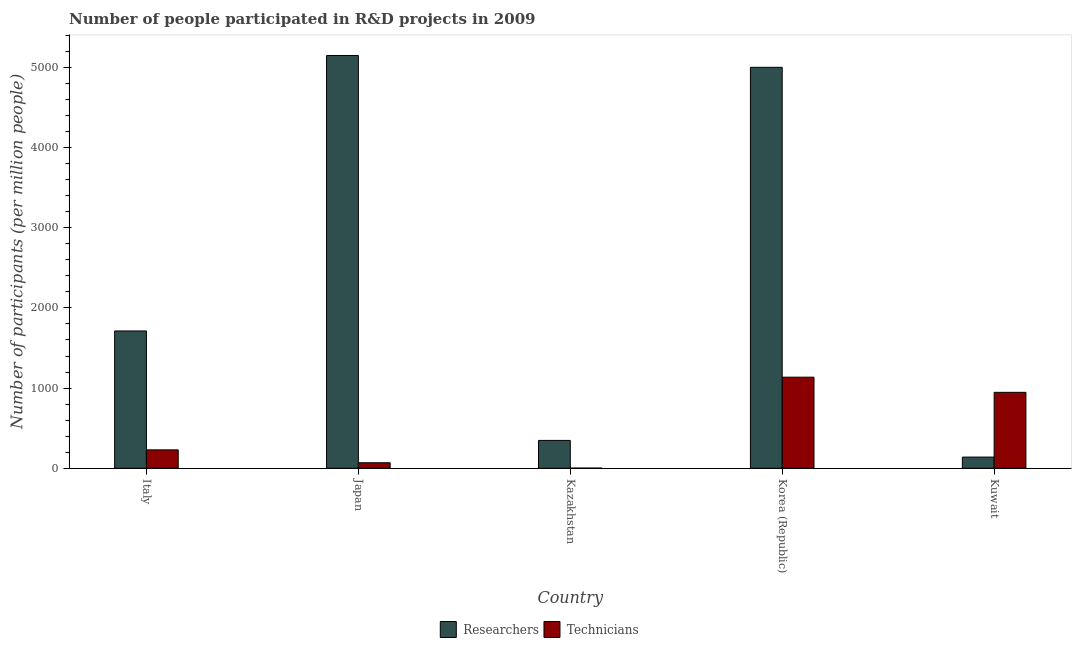How many different coloured bars are there?
Make the answer very short. 2. How many groups of bars are there?
Keep it short and to the point. 5. Are the number of bars per tick equal to the number of legend labels?
Provide a short and direct response. Yes. What is the label of the 2nd group of bars from the left?
Your answer should be very brief. Japan. In how many cases, is the number of bars for a given country not equal to the number of legend labels?
Ensure brevity in your answer.  0. What is the number of technicians in Kazakhstan?
Keep it short and to the point. 2.01. Across all countries, what is the maximum number of researchers?
Your answer should be compact. 5147.84. Across all countries, what is the minimum number of technicians?
Offer a terse response. 2.01. In which country was the number of researchers maximum?
Make the answer very short. Japan. In which country was the number of researchers minimum?
Give a very brief answer. Kuwait. What is the total number of technicians in the graph?
Offer a terse response. 2383.41. What is the difference between the number of researchers in Italy and that in Kuwait?
Keep it short and to the point. 1573.02. What is the difference between the number of researchers in Italy and the number of technicians in Kazakhstan?
Provide a succinct answer. 1710.54. What is the average number of technicians per country?
Your answer should be very brief. 476.68. What is the difference between the number of technicians and number of researchers in Korea (Republic)?
Make the answer very short. -3864.88. What is the ratio of the number of technicians in Japan to that in Korea (Republic)?
Provide a short and direct response. 0.06. Is the number of researchers in Italy less than that in Kazakhstan?
Ensure brevity in your answer.  No. What is the difference between the highest and the second highest number of technicians?
Make the answer very short. 188.9. What is the difference between the highest and the lowest number of technicians?
Provide a succinct answer. 1133.97. In how many countries, is the number of technicians greater than the average number of technicians taken over all countries?
Your answer should be very brief. 2. What does the 2nd bar from the left in Italy represents?
Keep it short and to the point. Technicians. What does the 2nd bar from the right in Japan represents?
Your answer should be very brief. Researchers. How many countries are there in the graph?
Your answer should be very brief. 5. Are the values on the major ticks of Y-axis written in scientific E-notation?
Provide a succinct answer. No. Does the graph contain any zero values?
Your answer should be very brief. No. Does the graph contain grids?
Your answer should be compact. No. Where does the legend appear in the graph?
Offer a terse response. Bottom center. What is the title of the graph?
Provide a short and direct response. Number of people participated in R&D projects in 2009. Does "Age 65(female)" appear as one of the legend labels in the graph?
Give a very brief answer. No. What is the label or title of the X-axis?
Keep it short and to the point. Country. What is the label or title of the Y-axis?
Provide a short and direct response. Number of participants (per million people). What is the Number of participants (per million people) in Researchers in Italy?
Your answer should be very brief. 1712.54. What is the Number of participants (per million people) in Technicians in Italy?
Provide a succinct answer. 229.5. What is the Number of participants (per million people) in Researchers in Japan?
Keep it short and to the point. 5147.84. What is the Number of participants (per million people) in Technicians in Japan?
Your answer should be very brief. 68.85. What is the Number of participants (per million people) of Researchers in Kazakhstan?
Ensure brevity in your answer.  347.43. What is the Number of participants (per million people) in Technicians in Kazakhstan?
Give a very brief answer. 2.01. What is the Number of participants (per million people) in Researchers in Korea (Republic)?
Your answer should be very brief. 5000.85. What is the Number of participants (per million people) of Technicians in Korea (Republic)?
Make the answer very short. 1135.98. What is the Number of participants (per million people) of Researchers in Kuwait?
Your response must be concise. 139.52. What is the Number of participants (per million people) of Technicians in Kuwait?
Your response must be concise. 947.07. Across all countries, what is the maximum Number of participants (per million people) in Researchers?
Keep it short and to the point. 5147.84. Across all countries, what is the maximum Number of participants (per million people) in Technicians?
Provide a short and direct response. 1135.98. Across all countries, what is the minimum Number of participants (per million people) in Researchers?
Offer a very short reply. 139.52. Across all countries, what is the minimum Number of participants (per million people) of Technicians?
Make the answer very short. 2.01. What is the total Number of participants (per million people) of Researchers in the graph?
Give a very brief answer. 1.23e+04. What is the total Number of participants (per million people) in Technicians in the graph?
Ensure brevity in your answer.  2383.41. What is the difference between the Number of participants (per million people) in Researchers in Italy and that in Japan?
Your answer should be very brief. -3435.29. What is the difference between the Number of participants (per million people) in Technicians in Italy and that in Japan?
Your answer should be very brief. 160.65. What is the difference between the Number of participants (per million people) in Researchers in Italy and that in Kazakhstan?
Provide a succinct answer. 1365.12. What is the difference between the Number of participants (per million people) of Technicians in Italy and that in Kazakhstan?
Ensure brevity in your answer.  227.49. What is the difference between the Number of participants (per million people) of Researchers in Italy and that in Korea (Republic)?
Provide a short and direct response. -3288.31. What is the difference between the Number of participants (per million people) of Technicians in Italy and that in Korea (Republic)?
Keep it short and to the point. -906.48. What is the difference between the Number of participants (per million people) in Researchers in Italy and that in Kuwait?
Keep it short and to the point. 1573.02. What is the difference between the Number of participants (per million people) of Technicians in Italy and that in Kuwait?
Your response must be concise. -717.58. What is the difference between the Number of participants (per million people) of Researchers in Japan and that in Kazakhstan?
Make the answer very short. 4800.41. What is the difference between the Number of participants (per million people) of Technicians in Japan and that in Kazakhstan?
Offer a terse response. 66.84. What is the difference between the Number of participants (per million people) in Researchers in Japan and that in Korea (Republic)?
Offer a very short reply. 146.98. What is the difference between the Number of participants (per million people) in Technicians in Japan and that in Korea (Republic)?
Offer a very short reply. -1067.13. What is the difference between the Number of participants (per million people) of Researchers in Japan and that in Kuwait?
Provide a short and direct response. 5008.31. What is the difference between the Number of participants (per million people) of Technicians in Japan and that in Kuwait?
Offer a very short reply. -878.22. What is the difference between the Number of participants (per million people) of Researchers in Kazakhstan and that in Korea (Republic)?
Give a very brief answer. -4653.43. What is the difference between the Number of participants (per million people) in Technicians in Kazakhstan and that in Korea (Republic)?
Give a very brief answer. -1133.97. What is the difference between the Number of participants (per million people) in Researchers in Kazakhstan and that in Kuwait?
Provide a succinct answer. 207.9. What is the difference between the Number of participants (per million people) in Technicians in Kazakhstan and that in Kuwait?
Provide a succinct answer. -945.07. What is the difference between the Number of participants (per million people) of Researchers in Korea (Republic) and that in Kuwait?
Give a very brief answer. 4861.33. What is the difference between the Number of participants (per million people) in Technicians in Korea (Republic) and that in Kuwait?
Your answer should be compact. 188.9. What is the difference between the Number of participants (per million people) of Researchers in Italy and the Number of participants (per million people) of Technicians in Japan?
Offer a terse response. 1643.69. What is the difference between the Number of participants (per million people) of Researchers in Italy and the Number of participants (per million people) of Technicians in Kazakhstan?
Offer a very short reply. 1710.54. What is the difference between the Number of participants (per million people) of Researchers in Italy and the Number of participants (per million people) of Technicians in Korea (Republic)?
Ensure brevity in your answer.  576.57. What is the difference between the Number of participants (per million people) in Researchers in Italy and the Number of participants (per million people) in Technicians in Kuwait?
Your answer should be very brief. 765.47. What is the difference between the Number of participants (per million people) in Researchers in Japan and the Number of participants (per million people) in Technicians in Kazakhstan?
Make the answer very short. 5145.83. What is the difference between the Number of participants (per million people) in Researchers in Japan and the Number of participants (per million people) in Technicians in Korea (Republic)?
Your response must be concise. 4011.86. What is the difference between the Number of participants (per million people) in Researchers in Japan and the Number of participants (per million people) in Technicians in Kuwait?
Give a very brief answer. 4200.76. What is the difference between the Number of participants (per million people) of Researchers in Kazakhstan and the Number of participants (per million people) of Technicians in Korea (Republic)?
Your response must be concise. -788.55. What is the difference between the Number of participants (per million people) in Researchers in Kazakhstan and the Number of participants (per million people) in Technicians in Kuwait?
Keep it short and to the point. -599.65. What is the difference between the Number of participants (per million people) in Researchers in Korea (Republic) and the Number of participants (per million people) in Technicians in Kuwait?
Your answer should be compact. 4053.78. What is the average Number of participants (per million people) of Researchers per country?
Make the answer very short. 2469.64. What is the average Number of participants (per million people) in Technicians per country?
Your answer should be compact. 476.68. What is the difference between the Number of participants (per million people) of Researchers and Number of participants (per million people) of Technicians in Italy?
Offer a terse response. 1483.05. What is the difference between the Number of participants (per million people) of Researchers and Number of participants (per million people) of Technicians in Japan?
Provide a succinct answer. 5078.99. What is the difference between the Number of participants (per million people) of Researchers and Number of participants (per million people) of Technicians in Kazakhstan?
Provide a succinct answer. 345.42. What is the difference between the Number of participants (per million people) of Researchers and Number of participants (per million people) of Technicians in Korea (Republic)?
Ensure brevity in your answer.  3864.88. What is the difference between the Number of participants (per million people) of Researchers and Number of participants (per million people) of Technicians in Kuwait?
Your response must be concise. -807.55. What is the ratio of the Number of participants (per million people) of Researchers in Italy to that in Japan?
Your response must be concise. 0.33. What is the ratio of the Number of participants (per million people) of Technicians in Italy to that in Japan?
Offer a terse response. 3.33. What is the ratio of the Number of participants (per million people) in Researchers in Italy to that in Kazakhstan?
Keep it short and to the point. 4.93. What is the ratio of the Number of participants (per million people) in Technicians in Italy to that in Kazakhstan?
Make the answer very short. 114.4. What is the ratio of the Number of participants (per million people) of Researchers in Italy to that in Korea (Republic)?
Ensure brevity in your answer.  0.34. What is the ratio of the Number of participants (per million people) of Technicians in Italy to that in Korea (Republic)?
Your answer should be very brief. 0.2. What is the ratio of the Number of participants (per million people) of Researchers in Italy to that in Kuwait?
Ensure brevity in your answer.  12.27. What is the ratio of the Number of participants (per million people) of Technicians in Italy to that in Kuwait?
Your answer should be compact. 0.24. What is the ratio of the Number of participants (per million people) of Researchers in Japan to that in Kazakhstan?
Provide a succinct answer. 14.82. What is the ratio of the Number of participants (per million people) in Technicians in Japan to that in Kazakhstan?
Provide a succinct answer. 34.32. What is the ratio of the Number of participants (per million people) of Researchers in Japan to that in Korea (Republic)?
Offer a very short reply. 1.03. What is the ratio of the Number of participants (per million people) of Technicians in Japan to that in Korea (Republic)?
Offer a very short reply. 0.06. What is the ratio of the Number of participants (per million people) of Researchers in Japan to that in Kuwait?
Offer a very short reply. 36.9. What is the ratio of the Number of participants (per million people) in Technicians in Japan to that in Kuwait?
Ensure brevity in your answer.  0.07. What is the ratio of the Number of participants (per million people) of Researchers in Kazakhstan to that in Korea (Republic)?
Provide a short and direct response. 0.07. What is the ratio of the Number of participants (per million people) of Technicians in Kazakhstan to that in Korea (Republic)?
Give a very brief answer. 0. What is the ratio of the Number of participants (per million people) of Researchers in Kazakhstan to that in Kuwait?
Offer a very short reply. 2.49. What is the ratio of the Number of participants (per million people) in Technicians in Kazakhstan to that in Kuwait?
Your answer should be compact. 0. What is the ratio of the Number of participants (per million people) in Researchers in Korea (Republic) to that in Kuwait?
Your answer should be very brief. 35.84. What is the ratio of the Number of participants (per million people) of Technicians in Korea (Republic) to that in Kuwait?
Give a very brief answer. 1.2. What is the difference between the highest and the second highest Number of participants (per million people) in Researchers?
Ensure brevity in your answer.  146.98. What is the difference between the highest and the second highest Number of participants (per million people) in Technicians?
Ensure brevity in your answer.  188.9. What is the difference between the highest and the lowest Number of participants (per million people) of Researchers?
Keep it short and to the point. 5008.31. What is the difference between the highest and the lowest Number of participants (per million people) of Technicians?
Provide a short and direct response. 1133.97. 